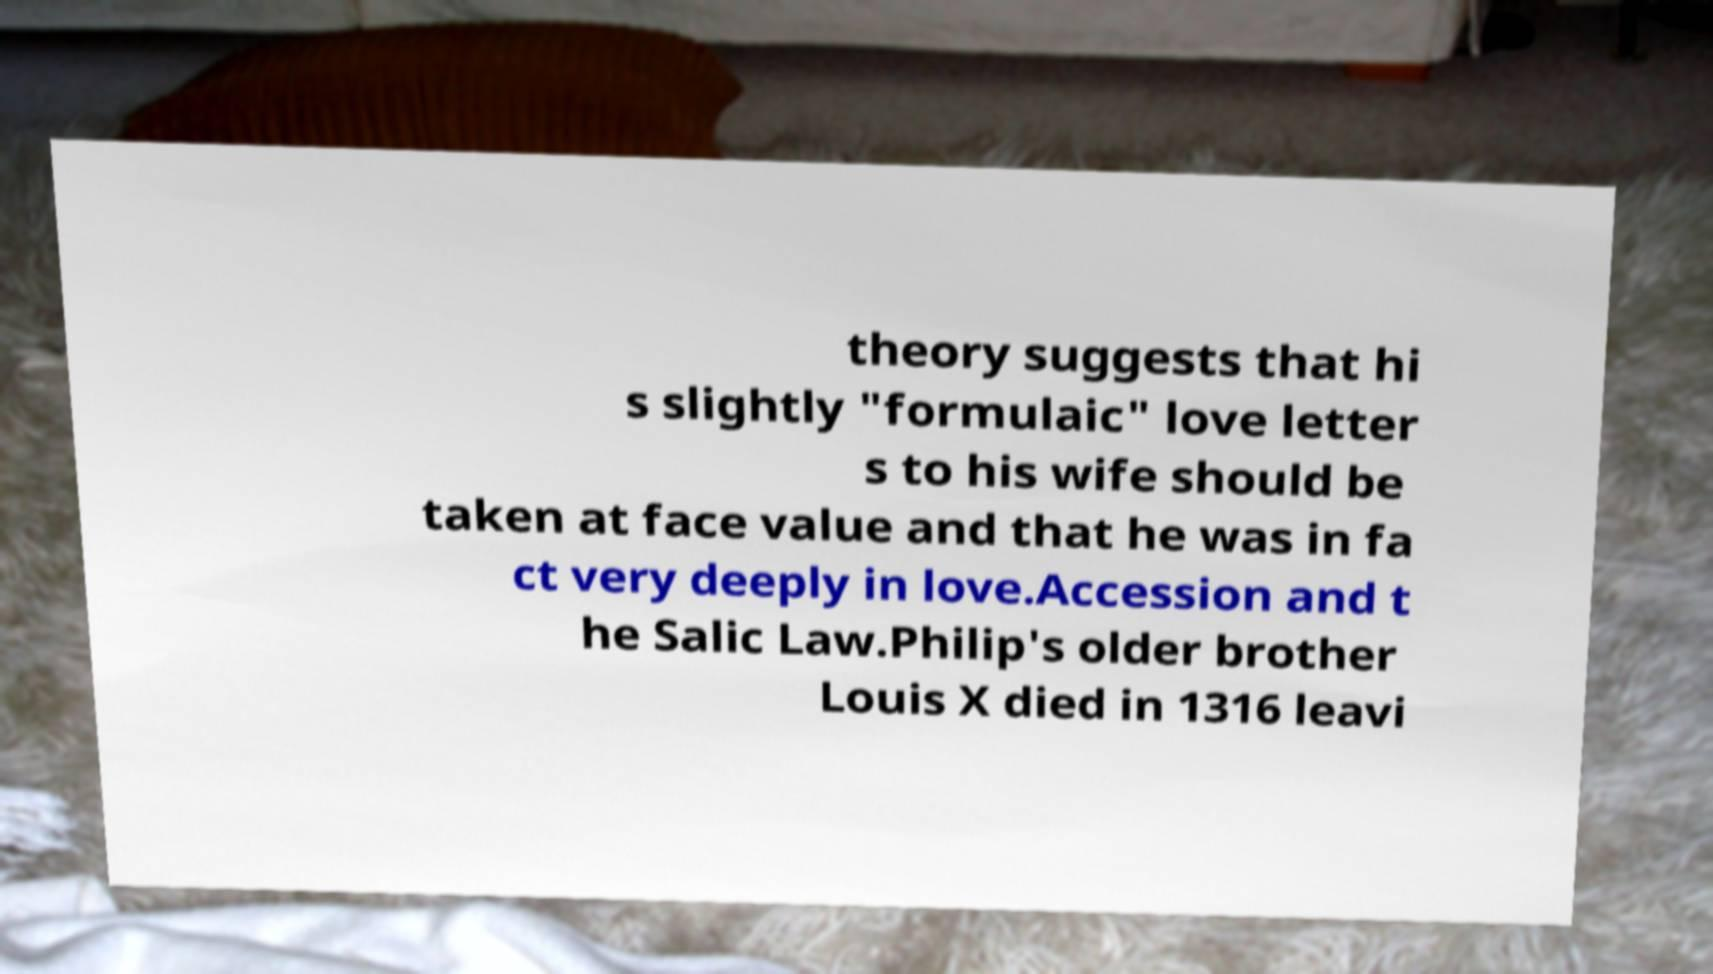Could you extract and type out the text from this image? theory suggests that hi s slightly "formulaic" love letter s to his wife should be taken at face value and that he was in fa ct very deeply in love.Accession and t he Salic Law.Philip's older brother Louis X died in 1316 leavi 